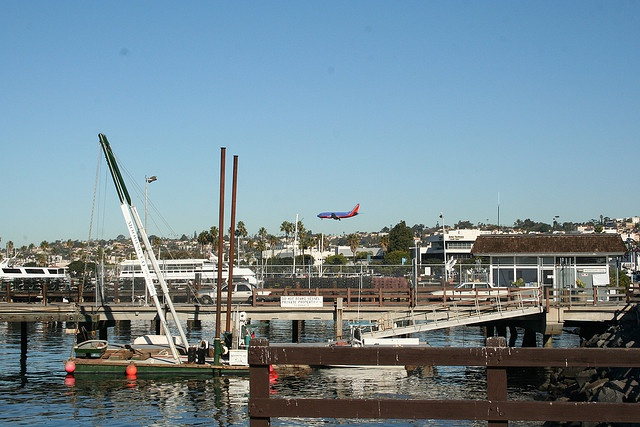Describe the objects in this image and their specific colors. I can see boat in gray, black, and darkgreen tones, car in gray, ivory, and darkgray tones, car in gray, black, beige, and darkgray tones, boat in gray, ivory, darkgray, and black tones, and boat in gray, black, and darkgray tones in this image. 